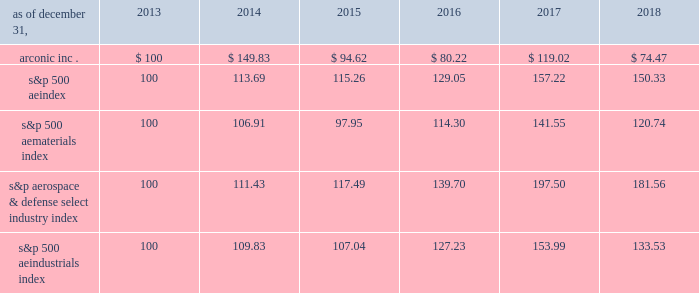Stock performance graph the following graph compares the most recent five-year performance of the company 2019s common stock with ( 1 ) the standard & poor 2019s ( s&p ) 500 ae index , ( 2 ) the s&p 500 ae materials index , a group of 25 companies categorized by standard & poor 2019s as active in the 201cmaterials 201d market sector , ( 3 ) the s&p aerospace & defense select industry index , a group of 33 companies categorized by standard & poor 2019s as active in the 201caerospace & defense 201d industry and ( 4 ) the s&p 500 ae industrials index , a group of 69 companies categorized by standard & poor 2019s as active in the 201cindustrials 201d market sector .
The graph assumes , in each case , an initial investment of $ 100 on december 31 , 2013 , and the reinvestment of dividends .
Historical prices prior to the separation of alcoa corporation from the company on november 1 , 2016 , have been adjusted to reflect the value of the separation transaction .
The graph , table and related information shall not be deemed to be 201cfiled 201d with the sec , nor shall such information be incorporated by reference into future filings under the securities act of 1933 or securities exchange act of 1934 , each as amended , except to the extent that the company specifically incorporates it by reference into such filing .
Please note that the company intends to replace the s&p 500 ae materials index with the s&p aerospace & defense select industry index and the s&p 500 ae industrials index in subsequent stock performance graphs .
We believe that the companies and industries represented in the s&p aerospace & defense select industry index and the s&p 500 ae industrials index better reflect the markets in which the company currently participates .
All three indices are represented in the graph below .
Arconic inc .
S&p 500 s&p materials s&p aerospace & defense s&p industrials cumulative total return based upon an initial investment of $ 100 at december 31 , 2013 with dividends reinvested 12/13 12/14 12/15 12/16 12/17 12/18 period ending copyright a9 2019 standard & poor's , a division of s&p global .
All rights reserved. .
S&p 500 ae index 100 113.69 115.26 129.05 157.22 150.33 s&p 500 ae materials index 100 106.91 97.95 114.30 141.55 120.74 s&p aerospace & defense select industry index 100 111.43 117.49 139.70 197.50 181.56 s&p 500 ae industrials index 100 109.83 107.04 127.23 153.99 133.53 .
Considering one year of investment , what is the variation between the return provided by arconic inc . and the one provided by s&p 500 aeindustrials index? 
Rationale: it is the difference between the percentage of return of the initial $ 100 in both indices .
Computations: (((149.83 / 100) - 1) - ((109.83 / 100) - 1))
Answer: 0.4. 